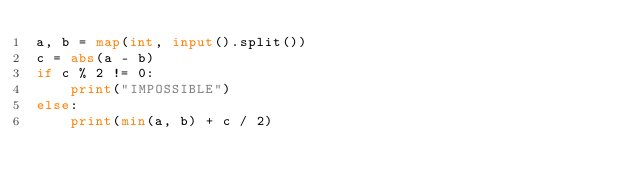Convert code to text. <code><loc_0><loc_0><loc_500><loc_500><_Python_>a, b = map(int, input().split())
c = abs(a - b) 
if c % 2 != 0:
    print("IMPOSSIBLE")
else:
    print(min(a, b) + c / 2)</code> 